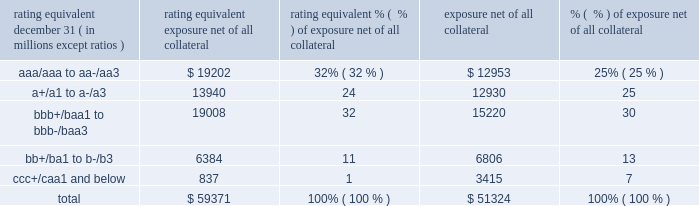Management 2019s discussion and analysis 126 jpmorgan chase & co./2014 annual report while useful as a current view of credit exposure , the net fair value of the derivative receivables does not capture the potential future variability of that credit exposure .
To capture the potential future variability of credit exposure , the firm calculates , on a client-by-client basis , three measures of potential derivatives-related credit loss : peak , derivative risk equivalent ( 201cdre 201d ) , and average exposure ( 201cavg 201d ) .
These measures all incorporate netting and collateral benefits , where applicable .
Peak exposure to a counterparty is an extreme measure of exposure calculated at a 97.5% ( 97.5 % ) confidence level .
Dre exposure is a measure that expresses the risk of derivative exposure on a basis intended to be equivalent to the risk of loan exposures .
The measurement is done by equating the unexpected loss in a derivative counterparty exposure ( which takes into consideration both the loss volatility and the credit rating of the counterparty ) with the unexpected loss in a loan exposure ( which takes into consideration only the credit rating of the counterparty ) .
Dre is a less extreme measure of potential credit loss than peak and is the primary measure used by the firm for credit approval of derivative transactions .
Finally , avg is a measure of the expected fair value of the firm 2019s derivative receivables at future time periods , including the benefit of collateral .
Avg exposure over the total life of the derivative contract is used as the primary metric for pricing purposes and is used to calculate credit capital and the cva , as further described below .
The three year avg exposure was $ 37.5 billion and $ 35.4 billion at december 31 , 2014 and 2013 , respectively , compared with derivative receivables , net of all collateral , of $ 59.4 billion and $ 51.3 billion at december 31 , 2014 and 2013 , respectively .
The fair value of the firm 2019s derivative receivables incorporates an adjustment , the cva , to reflect the credit quality of counterparties .
The cva is based on the firm 2019s avg to a counterparty and the counterparty 2019s credit spread in the credit derivatives market .
The primary components of changes in cva are credit spreads , new deal activity or unwinds , and changes in the underlying market environment .
The firm believes that active risk management is essential to controlling the dynamic credit risk in the derivatives portfolio .
In addition , the firm 2019s risk management process takes into consideration the potential impact of wrong-way risk , which is broadly defined as the potential for increased correlation between the firm 2019s exposure to a counterparty ( avg ) and the counterparty 2019s credit quality .
Many factors may influence the nature and magnitude of these correlations over time .
To the extent that these correlations are identified , the firm may adjust the cva associated with that counterparty 2019s avg .
The firm risk manages exposure to changes in cva by entering into credit derivative transactions , as well as interest rate , foreign exchange , equity and commodity derivative transactions .
The accompanying graph shows exposure profiles to the firm 2019s current derivatives portfolio over the next 10 years as calculated by the dre and avg metrics .
The two measures generally show that exposure will decline after the first year , if no new trades are added to the portfolio .
The table summarizes the ratings profile by derivative counterparty of the firm 2019s derivative receivables , including credit derivatives , net of other liquid securities collateral , for the dates indicated .
The ratings scale is based on the firm 2019s internal ratings , which generally correspond to the ratings as defined by s&p and moody 2019s .
Ratings profile of derivative receivables rating equivalent 2014 2013 ( a ) december 31 , ( in millions , except ratios ) exposure net of all collateral % (  % ) of exposure net of all collateral exposure net of all collateral % (  % ) of exposure net of all collateral .
( a ) the prior period amounts have been revised to conform with the current period presentation. .
What percent of the ratings profile of derivative receivables were junk rated in 2013? 
Computations: (13 + 7)
Answer: 20.0. 